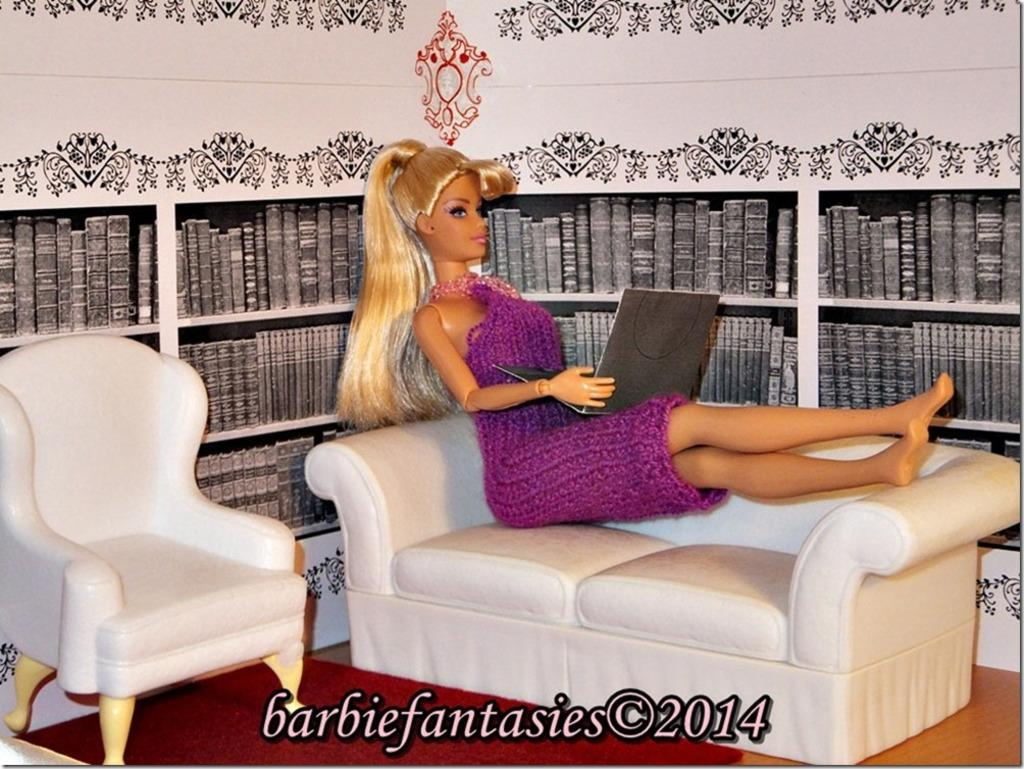What is the main subject of the image? The main subject of the image is a Barbie doll. Where is the Barbie doll located in the image? The Barbie doll is sitting on a sofa. What is the Barbie doll doing on the sofa? The Barbie doll is placing a laptop on her legs. What can be seen beside the sofa in the image? There is a chair beside the sofa. What is visible in the background of the image? There is a shelf in the background of the image. What is on the shelf? There are books placed on the shelf. What decision is the Barbie doll making about her teaching career in the image? There is no indication in the image that the Barbie doll is making any decisions about her teaching career. 